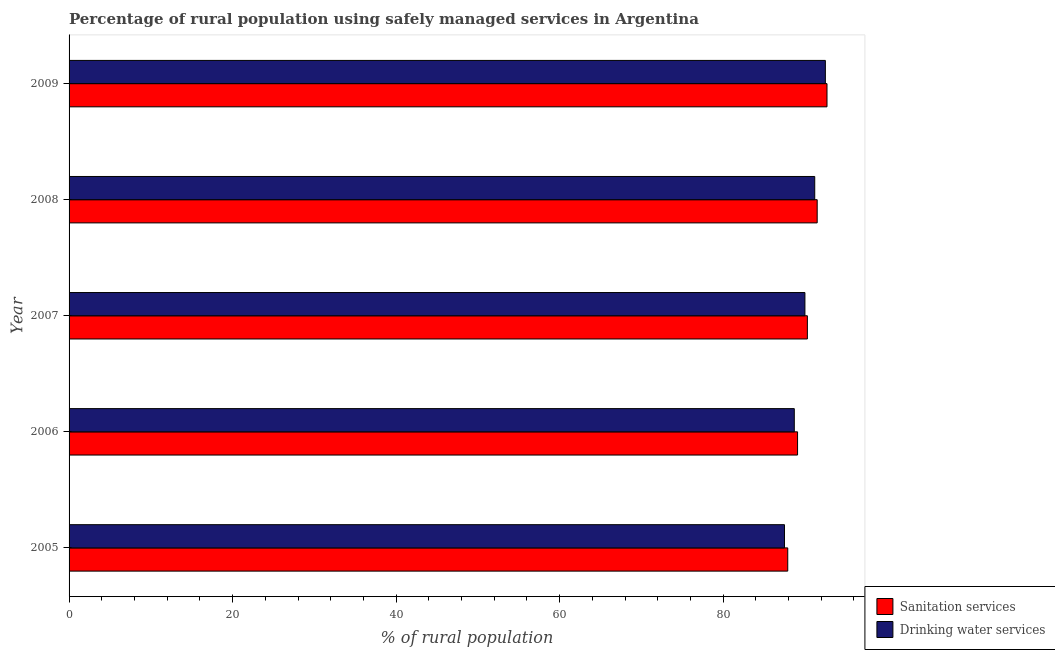How many different coloured bars are there?
Your response must be concise. 2. How many groups of bars are there?
Your response must be concise. 5. Are the number of bars on each tick of the Y-axis equal?
Provide a short and direct response. Yes. How many bars are there on the 4th tick from the top?
Provide a short and direct response. 2. How many bars are there on the 2nd tick from the bottom?
Offer a terse response. 2. What is the label of the 1st group of bars from the top?
Make the answer very short. 2009. In how many cases, is the number of bars for a given year not equal to the number of legend labels?
Your answer should be compact. 0. What is the percentage of rural population who used drinking water services in 2008?
Your answer should be compact. 91.2. Across all years, what is the maximum percentage of rural population who used drinking water services?
Give a very brief answer. 92.5. Across all years, what is the minimum percentage of rural population who used drinking water services?
Ensure brevity in your answer.  87.5. In which year was the percentage of rural population who used drinking water services maximum?
Offer a very short reply. 2009. What is the total percentage of rural population who used sanitation services in the graph?
Your answer should be very brief. 451.5. What is the difference between the percentage of rural population who used drinking water services in 2009 and the percentage of rural population who used sanitation services in 2005?
Your response must be concise. 4.6. What is the average percentage of rural population who used sanitation services per year?
Keep it short and to the point. 90.3. In the year 2009, what is the difference between the percentage of rural population who used sanitation services and percentage of rural population who used drinking water services?
Give a very brief answer. 0.2. In how many years, is the percentage of rural population who used drinking water services greater than 80 %?
Give a very brief answer. 5. Is the difference between the percentage of rural population who used sanitation services in 2005 and 2006 greater than the difference between the percentage of rural population who used drinking water services in 2005 and 2006?
Offer a very short reply. Yes. What is the difference between the highest and the second highest percentage of rural population who used sanitation services?
Offer a terse response. 1.2. Is the sum of the percentage of rural population who used drinking water services in 2007 and 2009 greater than the maximum percentage of rural population who used sanitation services across all years?
Give a very brief answer. Yes. What does the 1st bar from the top in 2007 represents?
Ensure brevity in your answer.  Drinking water services. What does the 2nd bar from the bottom in 2009 represents?
Your answer should be compact. Drinking water services. How many bars are there?
Offer a terse response. 10. How many years are there in the graph?
Provide a succinct answer. 5. What is the difference between two consecutive major ticks on the X-axis?
Your answer should be compact. 20. Does the graph contain grids?
Give a very brief answer. No. How many legend labels are there?
Your answer should be compact. 2. What is the title of the graph?
Your response must be concise. Percentage of rural population using safely managed services in Argentina. Does "All education staff compensation" appear as one of the legend labels in the graph?
Give a very brief answer. No. What is the label or title of the X-axis?
Give a very brief answer. % of rural population. What is the label or title of the Y-axis?
Provide a short and direct response. Year. What is the % of rural population of Sanitation services in 2005?
Ensure brevity in your answer.  87.9. What is the % of rural population in Drinking water services in 2005?
Offer a terse response. 87.5. What is the % of rural population in Sanitation services in 2006?
Make the answer very short. 89.1. What is the % of rural population in Drinking water services in 2006?
Offer a terse response. 88.7. What is the % of rural population of Sanitation services in 2007?
Your answer should be compact. 90.3. What is the % of rural population of Sanitation services in 2008?
Keep it short and to the point. 91.5. What is the % of rural population in Drinking water services in 2008?
Give a very brief answer. 91.2. What is the % of rural population of Sanitation services in 2009?
Make the answer very short. 92.7. What is the % of rural population of Drinking water services in 2009?
Your answer should be compact. 92.5. Across all years, what is the maximum % of rural population in Sanitation services?
Your answer should be compact. 92.7. Across all years, what is the maximum % of rural population of Drinking water services?
Give a very brief answer. 92.5. Across all years, what is the minimum % of rural population in Sanitation services?
Provide a short and direct response. 87.9. Across all years, what is the minimum % of rural population in Drinking water services?
Your answer should be very brief. 87.5. What is the total % of rural population in Sanitation services in the graph?
Ensure brevity in your answer.  451.5. What is the total % of rural population of Drinking water services in the graph?
Provide a short and direct response. 449.9. What is the difference between the % of rural population of Drinking water services in 2005 and that in 2008?
Provide a short and direct response. -3.7. What is the difference between the % of rural population in Sanitation services in 2006 and that in 2008?
Make the answer very short. -2.4. What is the difference between the % of rural population of Drinking water services in 2006 and that in 2008?
Provide a short and direct response. -2.5. What is the difference between the % of rural population in Sanitation services in 2006 and that in 2009?
Offer a terse response. -3.6. What is the difference between the % of rural population in Sanitation services in 2008 and that in 2009?
Your answer should be very brief. -1.2. What is the difference between the % of rural population in Drinking water services in 2008 and that in 2009?
Provide a short and direct response. -1.3. What is the difference between the % of rural population in Sanitation services in 2005 and the % of rural population in Drinking water services in 2007?
Your answer should be compact. -2.1. What is the difference between the % of rural population of Sanitation services in 2005 and the % of rural population of Drinking water services in 2008?
Your answer should be compact. -3.3. What is the difference between the % of rural population of Sanitation services in 2006 and the % of rural population of Drinking water services in 2008?
Provide a short and direct response. -2.1. What is the difference between the % of rural population of Sanitation services in 2006 and the % of rural population of Drinking water services in 2009?
Your answer should be very brief. -3.4. What is the difference between the % of rural population in Sanitation services in 2007 and the % of rural population in Drinking water services in 2009?
Offer a very short reply. -2.2. What is the difference between the % of rural population of Sanitation services in 2008 and the % of rural population of Drinking water services in 2009?
Offer a terse response. -1. What is the average % of rural population in Sanitation services per year?
Provide a succinct answer. 90.3. What is the average % of rural population in Drinking water services per year?
Provide a short and direct response. 89.98. In the year 2006, what is the difference between the % of rural population of Sanitation services and % of rural population of Drinking water services?
Provide a short and direct response. 0.4. In the year 2007, what is the difference between the % of rural population of Sanitation services and % of rural population of Drinking water services?
Your answer should be very brief. 0.3. In the year 2008, what is the difference between the % of rural population in Sanitation services and % of rural population in Drinking water services?
Give a very brief answer. 0.3. In the year 2009, what is the difference between the % of rural population of Sanitation services and % of rural population of Drinking water services?
Offer a terse response. 0.2. What is the ratio of the % of rural population in Sanitation services in 2005 to that in 2006?
Make the answer very short. 0.99. What is the ratio of the % of rural population of Drinking water services in 2005 to that in 2006?
Your answer should be compact. 0.99. What is the ratio of the % of rural population in Sanitation services in 2005 to that in 2007?
Make the answer very short. 0.97. What is the ratio of the % of rural population in Drinking water services in 2005 to that in 2007?
Provide a succinct answer. 0.97. What is the ratio of the % of rural population of Sanitation services in 2005 to that in 2008?
Your answer should be compact. 0.96. What is the ratio of the % of rural population in Drinking water services in 2005 to that in 2008?
Offer a terse response. 0.96. What is the ratio of the % of rural population of Sanitation services in 2005 to that in 2009?
Make the answer very short. 0.95. What is the ratio of the % of rural population in Drinking water services in 2005 to that in 2009?
Offer a very short reply. 0.95. What is the ratio of the % of rural population of Sanitation services in 2006 to that in 2007?
Your answer should be compact. 0.99. What is the ratio of the % of rural population in Drinking water services in 2006 to that in 2007?
Ensure brevity in your answer.  0.99. What is the ratio of the % of rural population of Sanitation services in 2006 to that in 2008?
Your answer should be very brief. 0.97. What is the ratio of the % of rural population in Drinking water services in 2006 to that in 2008?
Your answer should be compact. 0.97. What is the ratio of the % of rural population of Sanitation services in 2006 to that in 2009?
Give a very brief answer. 0.96. What is the ratio of the % of rural population of Drinking water services in 2006 to that in 2009?
Give a very brief answer. 0.96. What is the ratio of the % of rural population of Sanitation services in 2007 to that in 2008?
Your response must be concise. 0.99. What is the ratio of the % of rural population in Drinking water services in 2007 to that in 2008?
Your answer should be compact. 0.99. What is the ratio of the % of rural population in Sanitation services in 2007 to that in 2009?
Provide a succinct answer. 0.97. What is the ratio of the % of rural population of Drinking water services in 2007 to that in 2009?
Offer a very short reply. 0.97. What is the ratio of the % of rural population of Sanitation services in 2008 to that in 2009?
Offer a very short reply. 0.99. What is the ratio of the % of rural population of Drinking water services in 2008 to that in 2009?
Offer a terse response. 0.99. What is the difference between the highest and the lowest % of rural population of Drinking water services?
Your answer should be very brief. 5. 